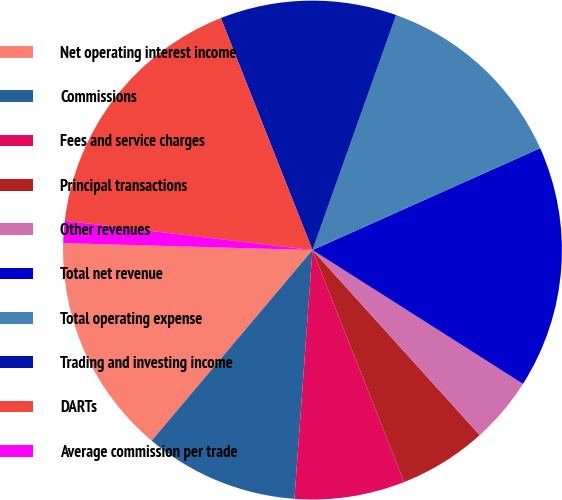<chart> <loc_0><loc_0><loc_500><loc_500><pie_chart><fcel>Net operating interest income<fcel>Commissions<fcel>Fees and service charges<fcel>Principal transactions<fcel>Other revenues<fcel>Total net revenue<fcel>Total operating expense<fcel>Trading and investing income<fcel>DARTs<fcel>Average commission per trade<nl><fcel>14.29%<fcel>10.0%<fcel>7.14%<fcel>5.71%<fcel>4.29%<fcel>15.71%<fcel>12.86%<fcel>11.43%<fcel>17.14%<fcel>1.43%<nl></chart> 